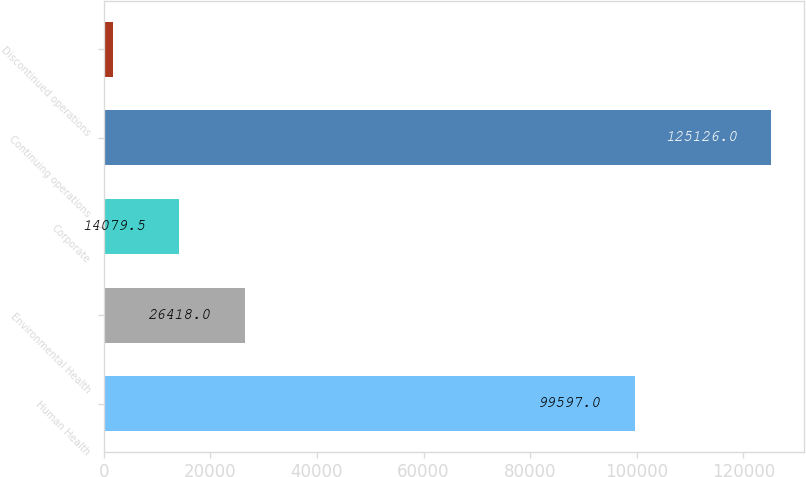Convert chart. <chart><loc_0><loc_0><loc_500><loc_500><bar_chart><fcel>Human Health<fcel>Environmental Health<fcel>Corporate<fcel>Continuing operations<fcel>Discontinued operations<nl><fcel>99597<fcel>26418<fcel>14079.5<fcel>125126<fcel>1741<nl></chart> 